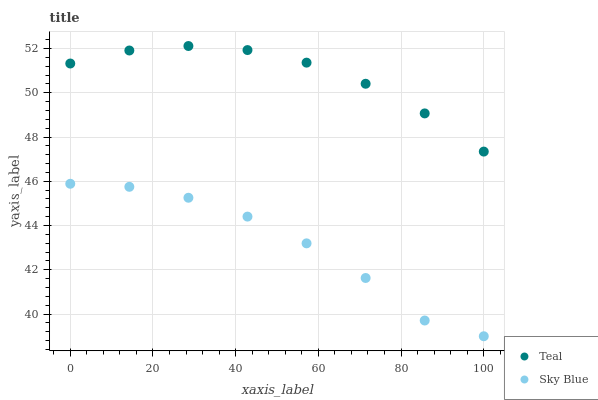Does Sky Blue have the minimum area under the curve?
Answer yes or no. Yes. Does Teal have the maximum area under the curve?
Answer yes or no. Yes. Does Teal have the minimum area under the curve?
Answer yes or no. No. Is Teal the smoothest?
Answer yes or no. Yes. Is Sky Blue the roughest?
Answer yes or no. Yes. Is Teal the roughest?
Answer yes or no. No. Does Sky Blue have the lowest value?
Answer yes or no. Yes. Does Teal have the lowest value?
Answer yes or no. No. Does Teal have the highest value?
Answer yes or no. Yes. Is Sky Blue less than Teal?
Answer yes or no. Yes. Is Teal greater than Sky Blue?
Answer yes or no. Yes. Does Sky Blue intersect Teal?
Answer yes or no. No. 